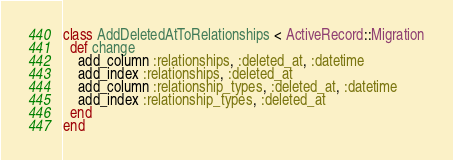Convert code to text. <code><loc_0><loc_0><loc_500><loc_500><_Ruby_>class AddDeletedAtToRelationships < ActiveRecord::Migration
  def change
    add_column :relationships, :deleted_at, :datetime
    add_index :relationships, :deleted_at
    add_column :relationship_types, :deleted_at, :datetime
    add_index :relationship_types, :deleted_at
  end
end
</code> 